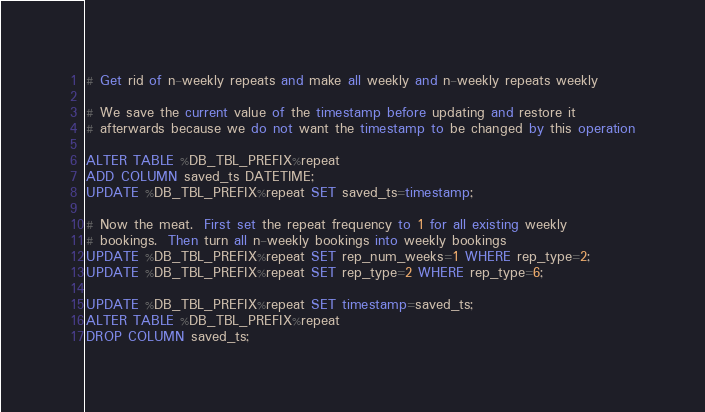Convert code to text. <code><loc_0><loc_0><loc_500><loc_500><_SQL_># Get rid of n-weekly repeats and make all weekly and n-weekly repeats weekly

# We save the current value of the timestamp before updating and restore it 
# afterwards because we do not want the timestamp to be changed by this operation

ALTER TABLE %DB_TBL_PREFIX%repeat
ADD COLUMN saved_ts DATETIME;
UPDATE %DB_TBL_PREFIX%repeat SET saved_ts=timestamp;

# Now the meat.  First set the repeat frequency to 1 for all existing weekly
# bookings.  Then turn all n-weekly bookings into weekly bookings
UPDATE %DB_TBL_PREFIX%repeat SET rep_num_weeks=1 WHERE rep_type=2;
UPDATE %DB_TBL_PREFIX%repeat SET rep_type=2 WHERE rep_type=6;

UPDATE %DB_TBL_PREFIX%repeat SET timestamp=saved_ts;
ALTER TABLE %DB_TBL_PREFIX%repeat
DROP COLUMN saved_ts;
</code> 